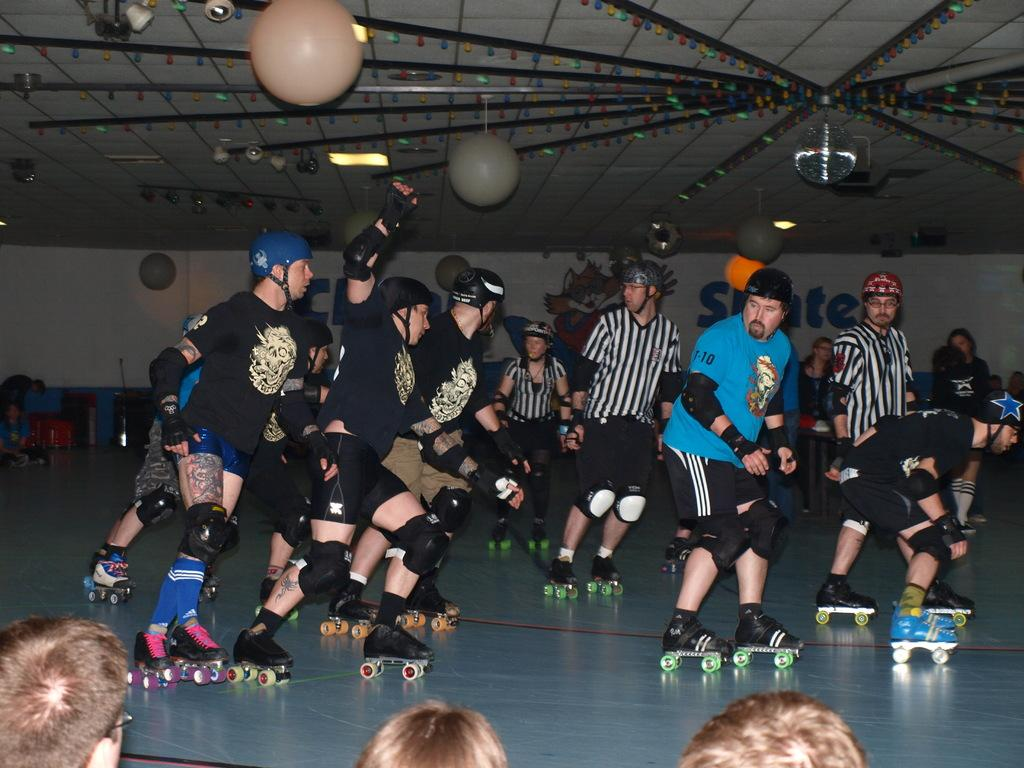What type of footwear are the people in the image wearing? The people in the image are wearing skate shoes. Where are the people located in the image? The people are on the floor. What can be seen on the ceiling in the image? There are lights on the ceiling. What is visible on the wall in the background of the image? There is text and an image on the wall in the background. What type of brass instrument is being played by the people in the image? There is no brass instrument present in the image; the people are wearing skate shoes and are not playing any instruments. 